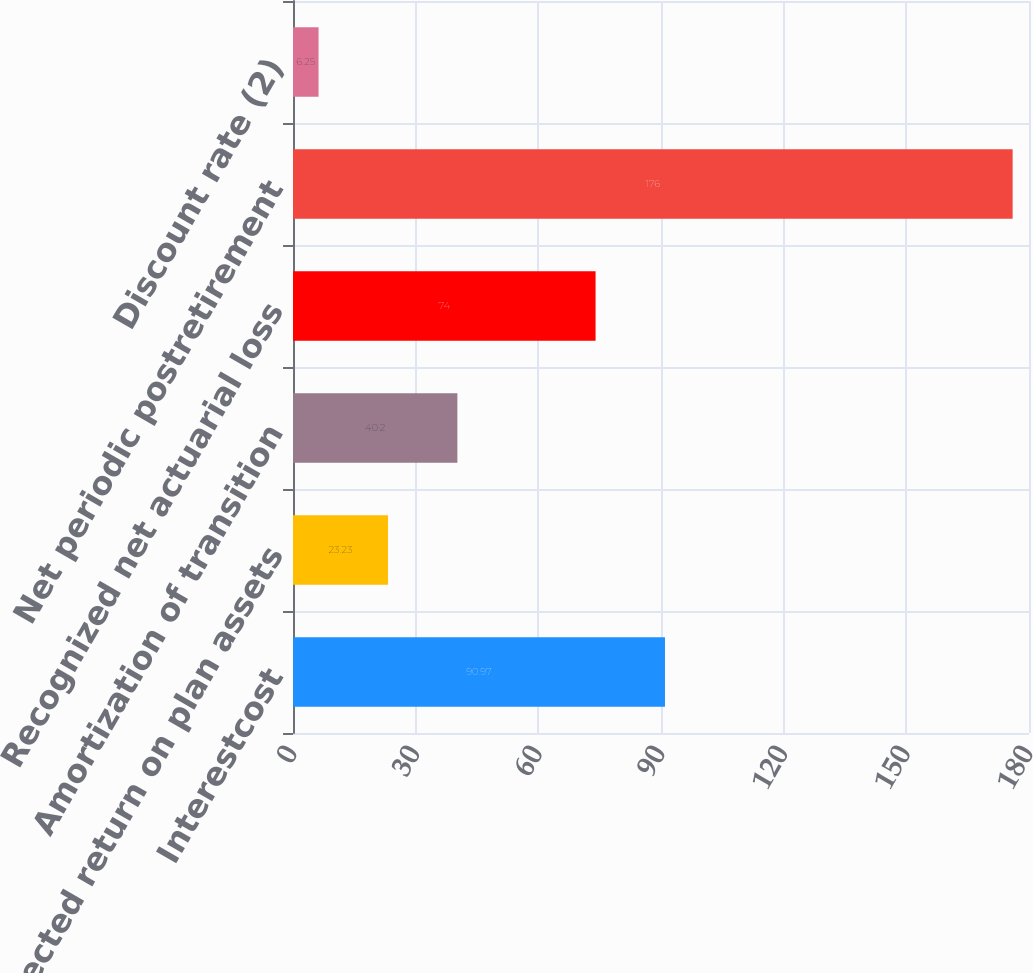Convert chart to OTSL. <chart><loc_0><loc_0><loc_500><loc_500><bar_chart><fcel>Interestcost<fcel>Expected return on plan assets<fcel>Amortization of transition<fcel>Recognized net actuarial loss<fcel>Net periodic postretirement<fcel>Discount rate (2)<nl><fcel>90.97<fcel>23.23<fcel>40.2<fcel>74<fcel>176<fcel>6.25<nl></chart> 